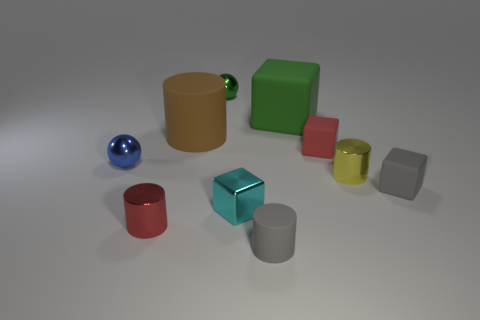Is the size of the green rubber cube the same as the yellow cylinder? No, the green rubber cube is not the same size as the yellow cylinder. The cube appears to have more uniform dimensions, whereas the cylinder is taller in height compared to its diameter. 